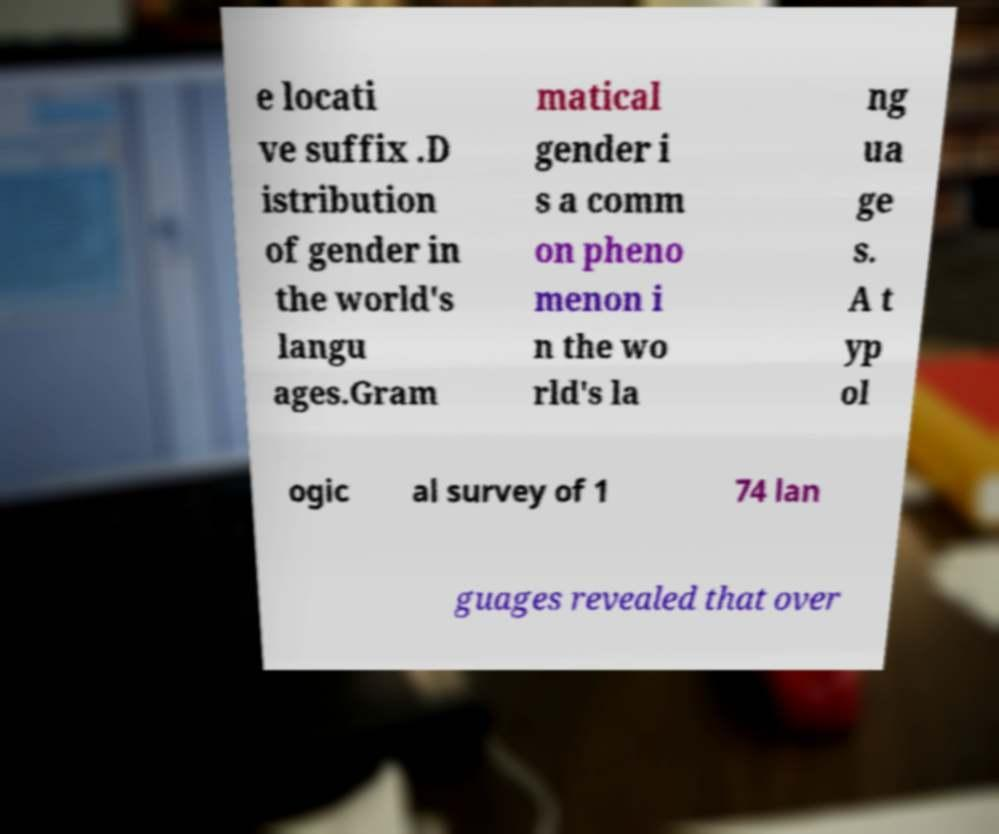I need the written content from this picture converted into text. Can you do that? e locati ve suffix .D istribution of gender in the world's langu ages.Gram matical gender i s a comm on pheno menon i n the wo rld's la ng ua ge s. A t yp ol ogic al survey of 1 74 lan guages revealed that over 